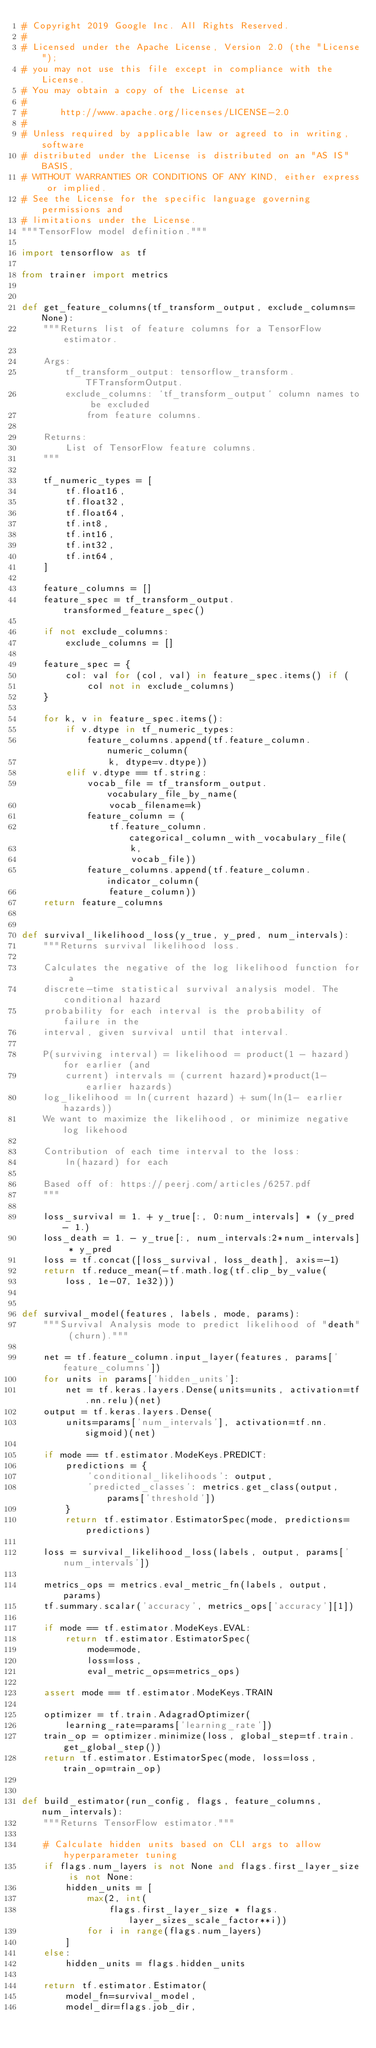Convert code to text. <code><loc_0><loc_0><loc_500><loc_500><_Python_># Copyright 2019 Google Inc. All Rights Reserved.
#
# Licensed under the Apache License, Version 2.0 (the "License");
# you may not use this file except in compliance with the License.
# You may obtain a copy of the License at
#
#      http://www.apache.org/licenses/LICENSE-2.0
#
# Unless required by applicable law or agreed to in writing, software
# distributed under the License is distributed on an "AS IS" BASIS,
# WITHOUT WARRANTIES OR CONDITIONS OF ANY KIND, either express or implied.
# See the License for the specific language governing permissions and
# limitations under the License.
"""TensorFlow model definition."""

import tensorflow as tf

from trainer import metrics


def get_feature_columns(tf_transform_output, exclude_columns=None):
    """Returns list of feature columns for a TensorFlow estimator.

    Args:
        tf_transform_output: tensorflow_transform.TFTransformOutput.
        exclude_columns: `tf_transform_output` column names to be excluded
            from feature columns.

    Returns:
        List of TensorFlow feature columns.
    """

    tf_numeric_types = [
        tf.float16,
        tf.float32,
        tf.float64,
        tf.int8,
        tf.int16,
        tf.int32,
        tf.int64,
    ]

    feature_columns = []
    feature_spec = tf_transform_output.transformed_feature_spec()

    if not exclude_columns:
        exclude_columns = []

    feature_spec = {
        col: val for (col, val) in feature_spec.items() if (
            col not in exclude_columns)
    }

    for k, v in feature_spec.items():
        if v.dtype in tf_numeric_types:
            feature_columns.append(tf.feature_column.numeric_column(
                k, dtype=v.dtype))
        elif v.dtype == tf.string:
            vocab_file = tf_transform_output.vocabulary_file_by_name(
                vocab_filename=k)
            feature_column = (
                tf.feature_column.categorical_column_with_vocabulary_file(
                    k,
                    vocab_file))
            feature_columns.append(tf.feature_column.indicator_column(
                feature_column))
    return feature_columns


def survival_likelihood_loss(y_true, y_pred, num_intervals):
    """Returns survival likelihood loss.

    Calculates the negative of the log likelihood function for a
    discrete-time statistical survival analysis model. The conditional hazard
    probability for each interval is the probability of failure in the
    interval, given survival until that interval.

    P(surviving interval) = likelihood = product(1 - hazard) for earlier (and
        current) intervals = (current hazard)*product(1- earlier hazards)
    log_likelihood = ln(current hazard) + sum(ln(1- earlier hazards))
    We want to maximize the likelihood, or minimize negative log likehood

    Contribution of each time interval to the loss:
        ln(hazard) for each

    Based off of: https://peerj.com/articles/6257.pdf
    """

    loss_survival = 1. + y_true[:, 0:num_intervals] * (y_pred - 1.)
    loss_death = 1. - y_true[:, num_intervals:2*num_intervals] * y_pred
    loss = tf.concat([loss_survival, loss_death], axis=-1)
    return tf.reduce_mean(-tf.math.log(tf.clip_by_value(
        loss, 1e-07, 1e32)))


def survival_model(features, labels, mode, params):
    """Survival Analysis mode to predict likelihood of "death" (churn)."""

    net = tf.feature_column.input_layer(features, params['feature_columns'])
    for units in params['hidden_units']:
        net = tf.keras.layers.Dense(units=units, activation=tf.nn.relu)(net)
    output = tf.keras.layers.Dense(
        units=params['num_intervals'], activation=tf.nn.sigmoid)(net)

    if mode == tf.estimator.ModeKeys.PREDICT:
        predictions = {
            'conditional_likelihoods': output,
            'predicted_classes': metrics.get_class(output, params['threshold'])
        }
        return tf.estimator.EstimatorSpec(mode, predictions=predictions)

    loss = survival_likelihood_loss(labels, output, params['num_intervals'])

    metrics_ops = metrics.eval_metric_fn(labels, output, params)
    tf.summary.scalar('accuracy', metrics_ops['accuracy'][1])

    if mode == tf.estimator.ModeKeys.EVAL:
        return tf.estimator.EstimatorSpec(
            mode=mode,
            loss=loss,
            eval_metric_ops=metrics_ops)

    assert mode == tf.estimator.ModeKeys.TRAIN

    optimizer = tf.train.AdagradOptimizer(
        learning_rate=params['learning_rate'])
    train_op = optimizer.minimize(loss, global_step=tf.train.get_global_step())
    return tf.estimator.EstimatorSpec(mode, loss=loss, train_op=train_op)


def build_estimator(run_config, flags, feature_columns, num_intervals):
    """Returns TensorFlow estimator."""

    # Calculate hidden units based on CLI args to allow hyperparameter tuning
    if flags.num_layers is not None and flags.first_layer_size is not None:
        hidden_units = [
            max(2, int(
                flags.first_layer_size * flags.layer_sizes_scale_factor**i))
            for i in range(flags.num_layers)
        ]
    else:
        hidden_units = flags.hidden_units

    return tf.estimator.Estimator(
        model_fn=survival_model,
        model_dir=flags.job_dir,</code> 